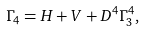<formula> <loc_0><loc_0><loc_500><loc_500>\Gamma _ { 4 } = H + V + D ^ { 4 } \Gamma _ { 3 } ^ { 4 } ,</formula> 